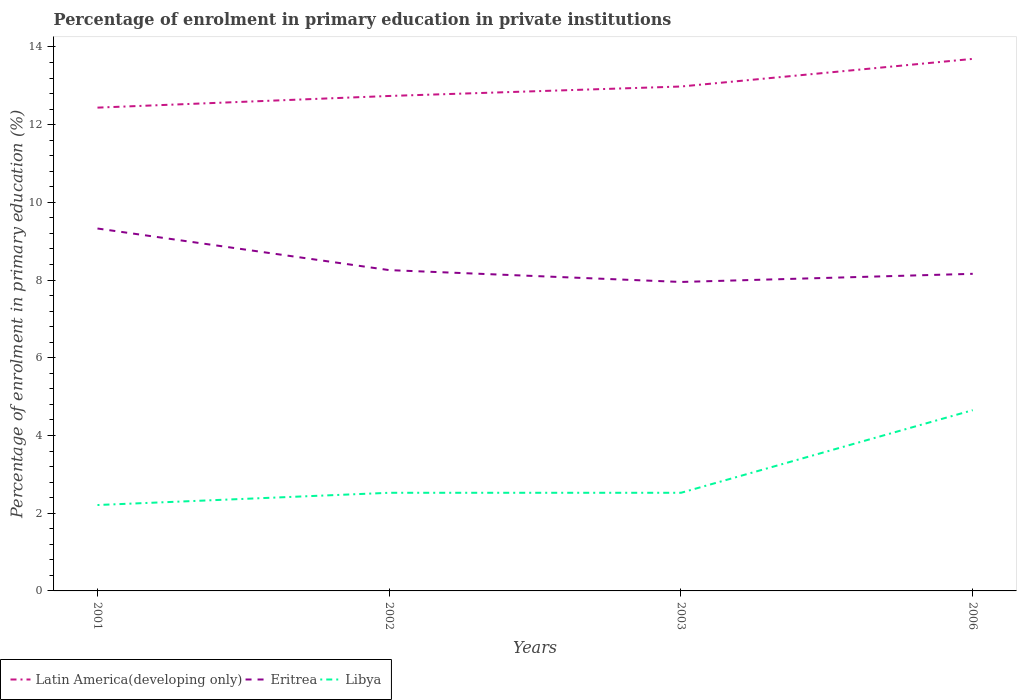How many different coloured lines are there?
Provide a short and direct response. 3. Is the number of lines equal to the number of legend labels?
Your answer should be compact. Yes. Across all years, what is the maximum percentage of enrolment in primary education in Libya?
Offer a very short reply. 2.21. What is the total percentage of enrolment in primary education in Libya in the graph?
Keep it short and to the point. -2.13. What is the difference between the highest and the second highest percentage of enrolment in primary education in Eritrea?
Make the answer very short. 1.38. Is the percentage of enrolment in primary education in Eritrea strictly greater than the percentage of enrolment in primary education in Libya over the years?
Your response must be concise. No. How many years are there in the graph?
Provide a short and direct response. 4. What is the difference between two consecutive major ticks on the Y-axis?
Provide a short and direct response. 2. Does the graph contain any zero values?
Offer a very short reply. No. Where does the legend appear in the graph?
Ensure brevity in your answer.  Bottom left. What is the title of the graph?
Offer a very short reply. Percentage of enrolment in primary education in private institutions. What is the label or title of the X-axis?
Your response must be concise. Years. What is the label or title of the Y-axis?
Give a very brief answer. Percentage of enrolment in primary education (%). What is the Percentage of enrolment in primary education (%) of Latin America(developing only) in 2001?
Your answer should be compact. 12.44. What is the Percentage of enrolment in primary education (%) in Eritrea in 2001?
Ensure brevity in your answer.  9.33. What is the Percentage of enrolment in primary education (%) in Libya in 2001?
Keep it short and to the point. 2.21. What is the Percentage of enrolment in primary education (%) in Latin America(developing only) in 2002?
Provide a succinct answer. 12.74. What is the Percentage of enrolment in primary education (%) of Eritrea in 2002?
Ensure brevity in your answer.  8.26. What is the Percentage of enrolment in primary education (%) in Libya in 2002?
Keep it short and to the point. 2.53. What is the Percentage of enrolment in primary education (%) of Latin America(developing only) in 2003?
Offer a very short reply. 12.98. What is the Percentage of enrolment in primary education (%) of Eritrea in 2003?
Your answer should be very brief. 7.95. What is the Percentage of enrolment in primary education (%) in Libya in 2003?
Offer a very short reply. 2.53. What is the Percentage of enrolment in primary education (%) in Latin America(developing only) in 2006?
Keep it short and to the point. 13.69. What is the Percentage of enrolment in primary education (%) of Eritrea in 2006?
Offer a very short reply. 8.16. What is the Percentage of enrolment in primary education (%) in Libya in 2006?
Your answer should be very brief. 4.65. Across all years, what is the maximum Percentage of enrolment in primary education (%) of Latin America(developing only)?
Your answer should be compact. 13.69. Across all years, what is the maximum Percentage of enrolment in primary education (%) in Eritrea?
Your answer should be very brief. 9.33. Across all years, what is the maximum Percentage of enrolment in primary education (%) of Libya?
Give a very brief answer. 4.65. Across all years, what is the minimum Percentage of enrolment in primary education (%) of Latin America(developing only)?
Your response must be concise. 12.44. Across all years, what is the minimum Percentage of enrolment in primary education (%) in Eritrea?
Offer a very short reply. 7.95. Across all years, what is the minimum Percentage of enrolment in primary education (%) in Libya?
Provide a short and direct response. 2.21. What is the total Percentage of enrolment in primary education (%) in Latin America(developing only) in the graph?
Keep it short and to the point. 51.85. What is the total Percentage of enrolment in primary education (%) of Eritrea in the graph?
Offer a terse response. 33.7. What is the total Percentage of enrolment in primary education (%) of Libya in the graph?
Your answer should be very brief. 11.91. What is the difference between the Percentage of enrolment in primary education (%) of Latin America(developing only) in 2001 and that in 2002?
Provide a succinct answer. -0.3. What is the difference between the Percentage of enrolment in primary education (%) in Eritrea in 2001 and that in 2002?
Offer a terse response. 1.07. What is the difference between the Percentage of enrolment in primary education (%) in Libya in 2001 and that in 2002?
Give a very brief answer. -0.32. What is the difference between the Percentage of enrolment in primary education (%) in Latin America(developing only) in 2001 and that in 2003?
Provide a succinct answer. -0.54. What is the difference between the Percentage of enrolment in primary education (%) in Eritrea in 2001 and that in 2003?
Keep it short and to the point. 1.38. What is the difference between the Percentage of enrolment in primary education (%) of Libya in 2001 and that in 2003?
Ensure brevity in your answer.  -0.32. What is the difference between the Percentage of enrolment in primary education (%) of Latin America(developing only) in 2001 and that in 2006?
Your answer should be compact. -1.25. What is the difference between the Percentage of enrolment in primary education (%) of Eritrea in 2001 and that in 2006?
Provide a short and direct response. 1.17. What is the difference between the Percentage of enrolment in primary education (%) of Libya in 2001 and that in 2006?
Offer a terse response. -2.44. What is the difference between the Percentage of enrolment in primary education (%) of Latin America(developing only) in 2002 and that in 2003?
Your answer should be very brief. -0.24. What is the difference between the Percentage of enrolment in primary education (%) in Eritrea in 2002 and that in 2003?
Provide a short and direct response. 0.3. What is the difference between the Percentage of enrolment in primary education (%) of Libya in 2002 and that in 2003?
Ensure brevity in your answer.  -0. What is the difference between the Percentage of enrolment in primary education (%) in Latin America(developing only) in 2002 and that in 2006?
Give a very brief answer. -0.95. What is the difference between the Percentage of enrolment in primary education (%) in Eritrea in 2002 and that in 2006?
Offer a terse response. 0.1. What is the difference between the Percentage of enrolment in primary education (%) of Libya in 2002 and that in 2006?
Ensure brevity in your answer.  -2.13. What is the difference between the Percentage of enrolment in primary education (%) of Latin America(developing only) in 2003 and that in 2006?
Your answer should be compact. -0.71. What is the difference between the Percentage of enrolment in primary education (%) in Eritrea in 2003 and that in 2006?
Give a very brief answer. -0.21. What is the difference between the Percentage of enrolment in primary education (%) of Libya in 2003 and that in 2006?
Provide a short and direct response. -2.13. What is the difference between the Percentage of enrolment in primary education (%) of Latin America(developing only) in 2001 and the Percentage of enrolment in primary education (%) of Eritrea in 2002?
Give a very brief answer. 4.18. What is the difference between the Percentage of enrolment in primary education (%) in Latin America(developing only) in 2001 and the Percentage of enrolment in primary education (%) in Libya in 2002?
Give a very brief answer. 9.91. What is the difference between the Percentage of enrolment in primary education (%) in Eritrea in 2001 and the Percentage of enrolment in primary education (%) in Libya in 2002?
Give a very brief answer. 6.8. What is the difference between the Percentage of enrolment in primary education (%) of Latin America(developing only) in 2001 and the Percentage of enrolment in primary education (%) of Eritrea in 2003?
Keep it short and to the point. 4.49. What is the difference between the Percentage of enrolment in primary education (%) of Latin America(developing only) in 2001 and the Percentage of enrolment in primary education (%) of Libya in 2003?
Provide a short and direct response. 9.91. What is the difference between the Percentage of enrolment in primary education (%) in Eritrea in 2001 and the Percentage of enrolment in primary education (%) in Libya in 2003?
Make the answer very short. 6.8. What is the difference between the Percentage of enrolment in primary education (%) of Latin America(developing only) in 2001 and the Percentage of enrolment in primary education (%) of Eritrea in 2006?
Offer a terse response. 4.28. What is the difference between the Percentage of enrolment in primary education (%) of Latin America(developing only) in 2001 and the Percentage of enrolment in primary education (%) of Libya in 2006?
Give a very brief answer. 7.79. What is the difference between the Percentage of enrolment in primary education (%) in Eritrea in 2001 and the Percentage of enrolment in primary education (%) in Libya in 2006?
Ensure brevity in your answer.  4.68. What is the difference between the Percentage of enrolment in primary education (%) in Latin America(developing only) in 2002 and the Percentage of enrolment in primary education (%) in Eritrea in 2003?
Provide a succinct answer. 4.79. What is the difference between the Percentage of enrolment in primary education (%) in Latin America(developing only) in 2002 and the Percentage of enrolment in primary education (%) in Libya in 2003?
Keep it short and to the point. 10.21. What is the difference between the Percentage of enrolment in primary education (%) in Eritrea in 2002 and the Percentage of enrolment in primary education (%) in Libya in 2003?
Offer a terse response. 5.73. What is the difference between the Percentage of enrolment in primary education (%) in Latin America(developing only) in 2002 and the Percentage of enrolment in primary education (%) in Eritrea in 2006?
Make the answer very short. 4.58. What is the difference between the Percentage of enrolment in primary education (%) in Latin America(developing only) in 2002 and the Percentage of enrolment in primary education (%) in Libya in 2006?
Provide a short and direct response. 8.09. What is the difference between the Percentage of enrolment in primary education (%) of Eritrea in 2002 and the Percentage of enrolment in primary education (%) of Libya in 2006?
Your response must be concise. 3.6. What is the difference between the Percentage of enrolment in primary education (%) in Latin America(developing only) in 2003 and the Percentage of enrolment in primary education (%) in Eritrea in 2006?
Your answer should be compact. 4.82. What is the difference between the Percentage of enrolment in primary education (%) in Latin America(developing only) in 2003 and the Percentage of enrolment in primary education (%) in Libya in 2006?
Ensure brevity in your answer.  8.33. What is the difference between the Percentage of enrolment in primary education (%) of Eritrea in 2003 and the Percentage of enrolment in primary education (%) of Libya in 2006?
Keep it short and to the point. 3.3. What is the average Percentage of enrolment in primary education (%) in Latin America(developing only) per year?
Offer a terse response. 12.96. What is the average Percentage of enrolment in primary education (%) in Eritrea per year?
Offer a very short reply. 8.42. What is the average Percentage of enrolment in primary education (%) in Libya per year?
Offer a terse response. 2.98. In the year 2001, what is the difference between the Percentage of enrolment in primary education (%) in Latin America(developing only) and Percentage of enrolment in primary education (%) in Eritrea?
Make the answer very short. 3.11. In the year 2001, what is the difference between the Percentage of enrolment in primary education (%) in Latin America(developing only) and Percentage of enrolment in primary education (%) in Libya?
Make the answer very short. 10.23. In the year 2001, what is the difference between the Percentage of enrolment in primary education (%) of Eritrea and Percentage of enrolment in primary education (%) of Libya?
Offer a very short reply. 7.12. In the year 2002, what is the difference between the Percentage of enrolment in primary education (%) in Latin America(developing only) and Percentage of enrolment in primary education (%) in Eritrea?
Offer a very short reply. 4.48. In the year 2002, what is the difference between the Percentage of enrolment in primary education (%) in Latin America(developing only) and Percentage of enrolment in primary education (%) in Libya?
Your response must be concise. 10.21. In the year 2002, what is the difference between the Percentage of enrolment in primary education (%) in Eritrea and Percentage of enrolment in primary education (%) in Libya?
Your response must be concise. 5.73. In the year 2003, what is the difference between the Percentage of enrolment in primary education (%) of Latin America(developing only) and Percentage of enrolment in primary education (%) of Eritrea?
Provide a short and direct response. 5.03. In the year 2003, what is the difference between the Percentage of enrolment in primary education (%) of Latin America(developing only) and Percentage of enrolment in primary education (%) of Libya?
Your response must be concise. 10.46. In the year 2003, what is the difference between the Percentage of enrolment in primary education (%) of Eritrea and Percentage of enrolment in primary education (%) of Libya?
Your answer should be very brief. 5.43. In the year 2006, what is the difference between the Percentage of enrolment in primary education (%) in Latin America(developing only) and Percentage of enrolment in primary education (%) in Eritrea?
Ensure brevity in your answer.  5.53. In the year 2006, what is the difference between the Percentage of enrolment in primary education (%) of Latin America(developing only) and Percentage of enrolment in primary education (%) of Libya?
Offer a very short reply. 9.04. In the year 2006, what is the difference between the Percentage of enrolment in primary education (%) of Eritrea and Percentage of enrolment in primary education (%) of Libya?
Ensure brevity in your answer.  3.51. What is the ratio of the Percentage of enrolment in primary education (%) of Latin America(developing only) in 2001 to that in 2002?
Your answer should be very brief. 0.98. What is the ratio of the Percentage of enrolment in primary education (%) of Eritrea in 2001 to that in 2002?
Make the answer very short. 1.13. What is the ratio of the Percentage of enrolment in primary education (%) of Libya in 2001 to that in 2002?
Offer a very short reply. 0.88. What is the ratio of the Percentage of enrolment in primary education (%) of Latin America(developing only) in 2001 to that in 2003?
Provide a succinct answer. 0.96. What is the ratio of the Percentage of enrolment in primary education (%) in Eritrea in 2001 to that in 2003?
Your answer should be very brief. 1.17. What is the ratio of the Percentage of enrolment in primary education (%) in Libya in 2001 to that in 2003?
Offer a very short reply. 0.88. What is the ratio of the Percentage of enrolment in primary education (%) of Latin America(developing only) in 2001 to that in 2006?
Your response must be concise. 0.91. What is the ratio of the Percentage of enrolment in primary education (%) of Libya in 2001 to that in 2006?
Provide a succinct answer. 0.48. What is the ratio of the Percentage of enrolment in primary education (%) in Latin America(developing only) in 2002 to that in 2003?
Your answer should be compact. 0.98. What is the ratio of the Percentage of enrolment in primary education (%) in Eritrea in 2002 to that in 2003?
Give a very brief answer. 1.04. What is the ratio of the Percentage of enrolment in primary education (%) of Libya in 2002 to that in 2003?
Ensure brevity in your answer.  1. What is the ratio of the Percentage of enrolment in primary education (%) in Latin America(developing only) in 2002 to that in 2006?
Keep it short and to the point. 0.93. What is the ratio of the Percentage of enrolment in primary education (%) in Eritrea in 2002 to that in 2006?
Your answer should be compact. 1.01. What is the ratio of the Percentage of enrolment in primary education (%) of Libya in 2002 to that in 2006?
Your answer should be compact. 0.54. What is the ratio of the Percentage of enrolment in primary education (%) in Latin America(developing only) in 2003 to that in 2006?
Your answer should be very brief. 0.95. What is the ratio of the Percentage of enrolment in primary education (%) of Eritrea in 2003 to that in 2006?
Offer a very short reply. 0.97. What is the ratio of the Percentage of enrolment in primary education (%) in Libya in 2003 to that in 2006?
Your answer should be very brief. 0.54. What is the difference between the highest and the second highest Percentage of enrolment in primary education (%) in Latin America(developing only)?
Offer a terse response. 0.71. What is the difference between the highest and the second highest Percentage of enrolment in primary education (%) of Eritrea?
Make the answer very short. 1.07. What is the difference between the highest and the second highest Percentage of enrolment in primary education (%) in Libya?
Your answer should be very brief. 2.13. What is the difference between the highest and the lowest Percentage of enrolment in primary education (%) of Latin America(developing only)?
Make the answer very short. 1.25. What is the difference between the highest and the lowest Percentage of enrolment in primary education (%) of Eritrea?
Provide a short and direct response. 1.38. What is the difference between the highest and the lowest Percentage of enrolment in primary education (%) of Libya?
Your answer should be compact. 2.44. 